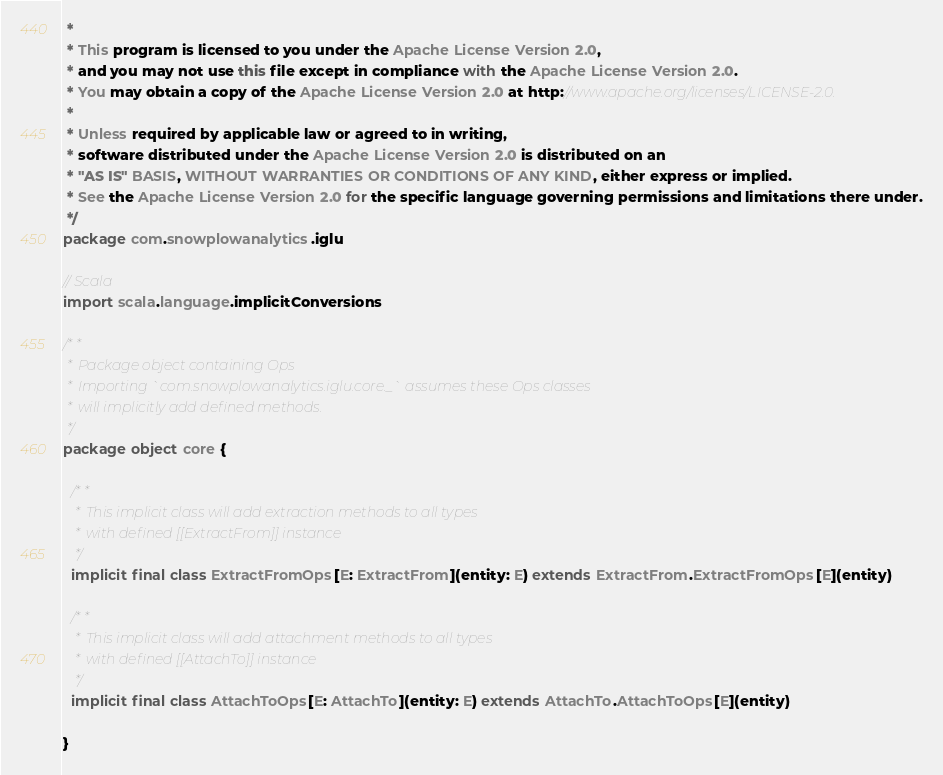Convert code to text. <code><loc_0><loc_0><loc_500><loc_500><_Scala_> *
 * This program is licensed to you under the Apache License Version 2.0,
 * and you may not use this file except in compliance with the Apache License Version 2.0.
 * You may obtain a copy of the Apache License Version 2.0 at http://www.apache.org/licenses/LICENSE-2.0.
 *
 * Unless required by applicable law or agreed to in writing,
 * software distributed under the Apache License Version 2.0 is distributed on an
 * "AS IS" BASIS, WITHOUT WARRANTIES OR CONDITIONS OF ANY KIND, either express or implied.
 * See the Apache License Version 2.0 for the specific language governing permissions and limitations there under.
 */
package com.snowplowanalytics.iglu

// Scala
import scala.language.implicitConversions

/**
 * Package object containing Ops
 * Importing `com.snowplowanalytics.iglu.core._` assumes these Ops classes
 * will implicitly add defined methods.
 */
package object core {

  /**
   * This implicit class will add extraction methods to all types
   * with defined [[ExtractFrom]] instance
   */
  implicit final class ExtractFromOps[E: ExtractFrom](entity: E) extends ExtractFrom.ExtractFromOps[E](entity)

  /**
   * This implicit class will add attachment methods to all types
   * with defined [[AttachTo]] instance
   */
  implicit final class AttachToOps[E: AttachTo](entity: E) extends AttachTo.AttachToOps[E](entity)

}
</code> 